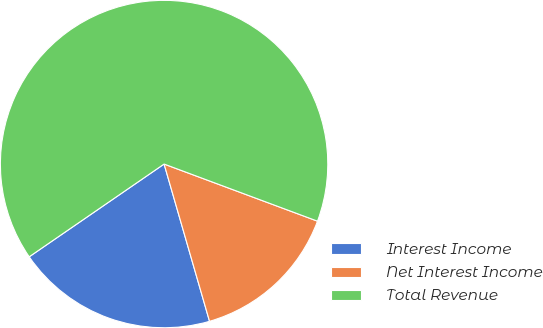Convert chart to OTSL. <chart><loc_0><loc_0><loc_500><loc_500><pie_chart><fcel>Interest Income<fcel>Net Interest Income<fcel>Total Revenue<nl><fcel>19.89%<fcel>14.85%<fcel>65.26%<nl></chart> 